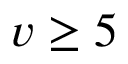<formula> <loc_0><loc_0><loc_500><loc_500>v \geq 5</formula> 